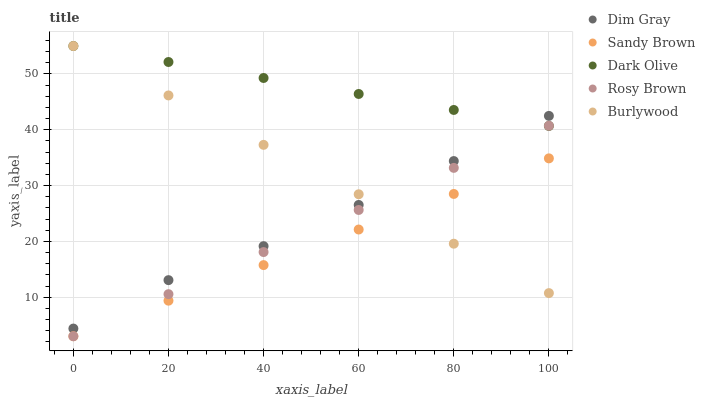Does Sandy Brown have the minimum area under the curve?
Answer yes or no. Yes. Does Dark Olive have the maximum area under the curve?
Answer yes or no. Yes. Does Burlywood have the minimum area under the curve?
Answer yes or no. No. Does Burlywood have the maximum area under the curve?
Answer yes or no. No. Is Rosy Brown the smoothest?
Answer yes or no. Yes. Is Dim Gray the roughest?
Answer yes or no. Yes. Is Burlywood the smoothest?
Answer yes or no. No. Is Burlywood the roughest?
Answer yes or no. No. Does Rosy Brown have the lowest value?
Answer yes or no. Yes. Does Burlywood have the lowest value?
Answer yes or no. No. Does Burlywood have the highest value?
Answer yes or no. Yes. Does Rosy Brown have the highest value?
Answer yes or no. No. Is Sandy Brown less than Dark Olive?
Answer yes or no. Yes. Is Dark Olive greater than Sandy Brown?
Answer yes or no. Yes. Does Rosy Brown intersect Sandy Brown?
Answer yes or no. Yes. Is Rosy Brown less than Sandy Brown?
Answer yes or no. No. Is Rosy Brown greater than Sandy Brown?
Answer yes or no. No. Does Sandy Brown intersect Dark Olive?
Answer yes or no. No. 